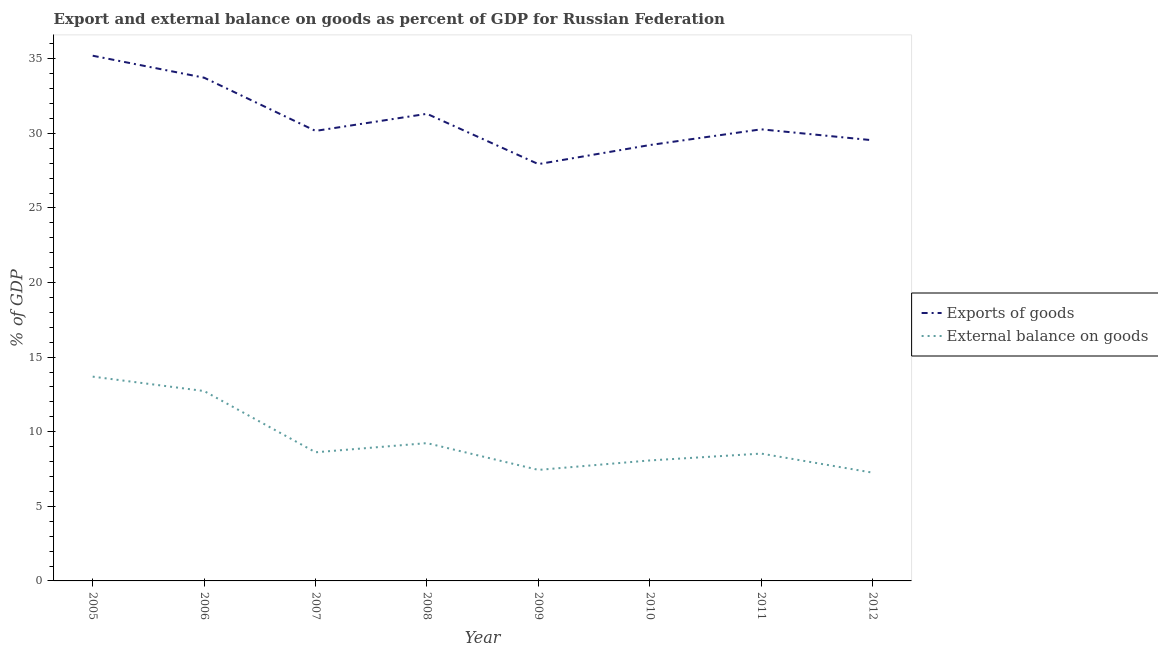Does the line corresponding to export of goods as percentage of gdp intersect with the line corresponding to external balance on goods as percentage of gdp?
Make the answer very short. No. What is the export of goods as percentage of gdp in 2012?
Keep it short and to the point. 29.54. Across all years, what is the maximum external balance on goods as percentage of gdp?
Your answer should be compact. 13.69. Across all years, what is the minimum external balance on goods as percentage of gdp?
Provide a succinct answer. 7.26. What is the total external balance on goods as percentage of gdp in the graph?
Offer a very short reply. 75.59. What is the difference between the external balance on goods as percentage of gdp in 2007 and that in 2008?
Offer a very short reply. -0.61. What is the difference between the export of goods as percentage of gdp in 2006 and the external balance on goods as percentage of gdp in 2005?
Offer a terse response. 20.04. What is the average external balance on goods as percentage of gdp per year?
Your answer should be very brief. 9.45. In the year 2005, what is the difference between the external balance on goods as percentage of gdp and export of goods as percentage of gdp?
Ensure brevity in your answer.  -21.51. In how many years, is the external balance on goods as percentage of gdp greater than 16 %?
Provide a succinct answer. 0. What is the ratio of the external balance on goods as percentage of gdp in 2007 to that in 2012?
Your answer should be compact. 1.19. Is the external balance on goods as percentage of gdp in 2008 less than that in 2010?
Ensure brevity in your answer.  No. Is the difference between the export of goods as percentage of gdp in 2007 and 2012 greater than the difference between the external balance on goods as percentage of gdp in 2007 and 2012?
Offer a very short reply. No. What is the difference between the highest and the second highest export of goods as percentage of gdp?
Your response must be concise. 1.47. What is the difference between the highest and the lowest export of goods as percentage of gdp?
Offer a terse response. 7.26. In how many years, is the external balance on goods as percentage of gdp greater than the average external balance on goods as percentage of gdp taken over all years?
Your answer should be compact. 2. Does the export of goods as percentage of gdp monotonically increase over the years?
Provide a succinct answer. No. Is the export of goods as percentage of gdp strictly greater than the external balance on goods as percentage of gdp over the years?
Offer a very short reply. Yes. Is the external balance on goods as percentage of gdp strictly less than the export of goods as percentage of gdp over the years?
Provide a succinct answer. Yes. What is the difference between two consecutive major ticks on the Y-axis?
Provide a succinct answer. 5. Are the values on the major ticks of Y-axis written in scientific E-notation?
Provide a short and direct response. No. Does the graph contain any zero values?
Your answer should be compact. No. Where does the legend appear in the graph?
Your answer should be very brief. Center right. What is the title of the graph?
Provide a short and direct response. Export and external balance on goods as percent of GDP for Russian Federation. Does "Travel services" appear as one of the legend labels in the graph?
Your answer should be compact. No. What is the label or title of the Y-axis?
Keep it short and to the point. % of GDP. What is the % of GDP of Exports of goods in 2005?
Your answer should be very brief. 35.2. What is the % of GDP in External balance on goods in 2005?
Your response must be concise. 13.69. What is the % of GDP of Exports of goods in 2006?
Provide a succinct answer. 33.73. What is the % of GDP of External balance on goods in 2006?
Make the answer very short. 12.73. What is the % of GDP in Exports of goods in 2007?
Provide a short and direct response. 30.16. What is the % of GDP in External balance on goods in 2007?
Provide a succinct answer. 8.62. What is the % of GDP of Exports of goods in 2008?
Your answer should be very brief. 31.31. What is the % of GDP in External balance on goods in 2008?
Provide a short and direct response. 9.24. What is the % of GDP in Exports of goods in 2009?
Keep it short and to the point. 27.94. What is the % of GDP of External balance on goods in 2009?
Keep it short and to the point. 7.44. What is the % of GDP of Exports of goods in 2010?
Provide a succinct answer. 29.22. What is the % of GDP of External balance on goods in 2010?
Provide a short and direct response. 8.08. What is the % of GDP in Exports of goods in 2011?
Give a very brief answer. 30.27. What is the % of GDP in External balance on goods in 2011?
Your response must be concise. 8.53. What is the % of GDP of Exports of goods in 2012?
Your answer should be very brief. 29.54. What is the % of GDP of External balance on goods in 2012?
Make the answer very short. 7.26. Across all years, what is the maximum % of GDP of Exports of goods?
Make the answer very short. 35.2. Across all years, what is the maximum % of GDP of External balance on goods?
Make the answer very short. 13.69. Across all years, what is the minimum % of GDP of Exports of goods?
Make the answer very short. 27.94. Across all years, what is the minimum % of GDP of External balance on goods?
Offer a very short reply. 7.26. What is the total % of GDP of Exports of goods in the graph?
Your answer should be very brief. 247.37. What is the total % of GDP in External balance on goods in the graph?
Offer a very short reply. 75.59. What is the difference between the % of GDP in Exports of goods in 2005 and that in 2006?
Your response must be concise. 1.47. What is the difference between the % of GDP of External balance on goods in 2005 and that in 2006?
Offer a terse response. 0.97. What is the difference between the % of GDP in Exports of goods in 2005 and that in 2007?
Your response must be concise. 5.04. What is the difference between the % of GDP of External balance on goods in 2005 and that in 2007?
Your response must be concise. 5.07. What is the difference between the % of GDP in Exports of goods in 2005 and that in 2008?
Your response must be concise. 3.89. What is the difference between the % of GDP in External balance on goods in 2005 and that in 2008?
Offer a terse response. 4.46. What is the difference between the % of GDP in Exports of goods in 2005 and that in 2009?
Offer a very short reply. 7.26. What is the difference between the % of GDP in External balance on goods in 2005 and that in 2009?
Your response must be concise. 6.25. What is the difference between the % of GDP in Exports of goods in 2005 and that in 2010?
Give a very brief answer. 5.99. What is the difference between the % of GDP of External balance on goods in 2005 and that in 2010?
Your answer should be compact. 5.62. What is the difference between the % of GDP of Exports of goods in 2005 and that in 2011?
Your answer should be very brief. 4.93. What is the difference between the % of GDP in External balance on goods in 2005 and that in 2011?
Ensure brevity in your answer.  5.16. What is the difference between the % of GDP of Exports of goods in 2005 and that in 2012?
Offer a very short reply. 5.67. What is the difference between the % of GDP of External balance on goods in 2005 and that in 2012?
Keep it short and to the point. 6.44. What is the difference between the % of GDP in Exports of goods in 2006 and that in 2007?
Offer a terse response. 3.57. What is the difference between the % of GDP of External balance on goods in 2006 and that in 2007?
Ensure brevity in your answer.  4.11. What is the difference between the % of GDP in Exports of goods in 2006 and that in 2008?
Give a very brief answer. 2.42. What is the difference between the % of GDP of External balance on goods in 2006 and that in 2008?
Keep it short and to the point. 3.49. What is the difference between the % of GDP of Exports of goods in 2006 and that in 2009?
Make the answer very short. 5.79. What is the difference between the % of GDP in External balance on goods in 2006 and that in 2009?
Your answer should be compact. 5.29. What is the difference between the % of GDP in Exports of goods in 2006 and that in 2010?
Your answer should be very brief. 4.51. What is the difference between the % of GDP in External balance on goods in 2006 and that in 2010?
Offer a terse response. 4.65. What is the difference between the % of GDP of Exports of goods in 2006 and that in 2011?
Make the answer very short. 3.46. What is the difference between the % of GDP of External balance on goods in 2006 and that in 2011?
Provide a short and direct response. 4.19. What is the difference between the % of GDP of Exports of goods in 2006 and that in 2012?
Provide a succinct answer. 4.19. What is the difference between the % of GDP in External balance on goods in 2006 and that in 2012?
Your answer should be compact. 5.47. What is the difference between the % of GDP in Exports of goods in 2007 and that in 2008?
Give a very brief answer. -1.15. What is the difference between the % of GDP in External balance on goods in 2007 and that in 2008?
Offer a very short reply. -0.61. What is the difference between the % of GDP of Exports of goods in 2007 and that in 2009?
Give a very brief answer. 2.23. What is the difference between the % of GDP of External balance on goods in 2007 and that in 2009?
Provide a succinct answer. 1.18. What is the difference between the % of GDP of Exports of goods in 2007 and that in 2010?
Keep it short and to the point. 0.95. What is the difference between the % of GDP of External balance on goods in 2007 and that in 2010?
Your answer should be very brief. 0.55. What is the difference between the % of GDP in Exports of goods in 2007 and that in 2011?
Provide a succinct answer. -0.11. What is the difference between the % of GDP of External balance on goods in 2007 and that in 2011?
Provide a short and direct response. 0.09. What is the difference between the % of GDP of Exports of goods in 2007 and that in 2012?
Ensure brevity in your answer.  0.63. What is the difference between the % of GDP of External balance on goods in 2007 and that in 2012?
Your answer should be compact. 1.37. What is the difference between the % of GDP in Exports of goods in 2008 and that in 2009?
Your answer should be very brief. 3.37. What is the difference between the % of GDP in External balance on goods in 2008 and that in 2009?
Make the answer very short. 1.8. What is the difference between the % of GDP in Exports of goods in 2008 and that in 2010?
Your answer should be very brief. 2.09. What is the difference between the % of GDP of External balance on goods in 2008 and that in 2010?
Give a very brief answer. 1.16. What is the difference between the % of GDP of Exports of goods in 2008 and that in 2011?
Offer a very short reply. 1.04. What is the difference between the % of GDP of External balance on goods in 2008 and that in 2011?
Your answer should be compact. 0.7. What is the difference between the % of GDP in Exports of goods in 2008 and that in 2012?
Provide a short and direct response. 1.77. What is the difference between the % of GDP in External balance on goods in 2008 and that in 2012?
Provide a succinct answer. 1.98. What is the difference between the % of GDP of Exports of goods in 2009 and that in 2010?
Make the answer very short. -1.28. What is the difference between the % of GDP of External balance on goods in 2009 and that in 2010?
Your answer should be very brief. -0.63. What is the difference between the % of GDP of Exports of goods in 2009 and that in 2011?
Provide a succinct answer. -2.33. What is the difference between the % of GDP in External balance on goods in 2009 and that in 2011?
Give a very brief answer. -1.09. What is the difference between the % of GDP in Exports of goods in 2009 and that in 2012?
Your answer should be compact. -1.6. What is the difference between the % of GDP in External balance on goods in 2009 and that in 2012?
Offer a very short reply. 0.18. What is the difference between the % of GDP in Exports of goods in 2010 and that in 2011?
Provide a short and direct response. -1.05. What is the difference between the % of GDP in External balance on goods in 2010 and that in 2011?
Give a very brief answer. -0.46. What is the difference between the % of GDP of Exports of goods in 2010 and that in 2012?
Offer a very short reply. -0.32. What is the difference between the % of GDP in External balance on goods in 2010 and that in 2012?
Provide a short and direct response. 0.82. What is the difference between the % of GDP in Exports of goods in 2011 and that in 2012?
Offer a terse response. 0.73. What is the difference between the % of GDP of External balance on goods in 2011 and that in 2012?
Provide a short and direct response. 1.28. What is the difference between the % of GDP in Exports of goods in 2005 and the % of GDP in External balance on goods in 2006?
Ensure brevity in your answer.  22.48. What is the difference between the % of GDP in Exports of goods in 2005 and the % of GDP in External balance on goods in 2007?
Make the answer very short. 26.58. What is the difference between the % of GDP in Exports of goods in 2005 and the % of GDP in External balance on goods in 2008?
Your response must be concise. 25.97. What is the difference between the % of GDP of Exports of goods in 2005 and the % of GDP of External balance on goods in 2009?
Your response must be concise. 27.76. What is the difference between the % of GDP in Exports of goods in 2005 and the % of GDP in External balance on goods in 2010?
Give a very brief answer. 27.13. What is the difference between the % of GDP in Exports of goods in 2005 and the % of GDP in External balance on goods in 2011?
Give a very brief answer. 26.67. What is the difference between the % of GDP in Exports of goods in 2005 and the % of GDP in External balance on goods in 2012?
Make the answer very short. 27.95. What is the difference between the % of GDP of Exports of goods in 2006 and the % of GDP of External balance on goods in 2007?
Your answer should be very brief. 25.11. What is the difference between the % of GDP in Exports of goods in 2006 and the % of GDP in External balance on goods in 2008?
Your response must be concise. 24.49. What is the difference between the % of GDP of Exports of goods in 2006 and the % of GDP of External balance on goods in 2009?
Keep it short and to the point. 26.29. What is the difference between the % of GDP of Exports of goods in 2006 and the % of GDP of External balance on goods in 2010?
Ensure brevity in your answer.  25.65. What is the difference between the % of GDP of Exports of goods in 2006 and the % of GDP of External balance on goods in 2011?
Your answer should be very brief. 25.2. What is the difference between the % of GDP in Exports of goods in 2006 and the % of GDP in External balance on goods in 2012?
Ensure brevity in your answer.  26.47. What is the difference between the % of GDP of Exports of goods in 2007 and the % of GDP of External balance on goods in 2008?
Give a very brief answer. 20.93. What is the difference between the % of GDP of Exports of goods in 2007 and the % of GDP of External balance on goods in 2009?
Your answer should be very brief. 22.72. What is the difference between the % of GDP of Exports of goods in 2007 and the % of GDP of External balance on goods in 2010?
Make the answer very short. 22.09. What is the difference between the % of GDP of Exports of goods in 2007 and the % of GDP of External balance on goods in 2011?
Provide a succinct answer. 21.63. What is the difference between the % of GDP in Exports of goods in 2007 and the % of GDP in External balance on goods in 2012?
Ensure brevity in your answer.  22.91. What is the difference between the % of GDP in Exports of goods in 2008 and the % of GDP in External balance on goods in 2009?
Your response must be concise. 23.87. What is the difference between the % of GDP in Exports of goods in 2008 and the % of GDP in External balance on goods in 2010?
Your response must be concise. 23.23. What is the difference between the % of GDP of Exports of goods in 2008 and the % of GDP of External balance on goods in 2011?
Your response must be concise. 22.78. What is the difference between the % of GDP of Exports of goods in 2008 and the % of GDP of External balance on goods in 2012?
Offer a terse response. 24.05. What is the difference between the % of GDP in Exports of goods in 2009 and the % of GDP in External balance on goods in 2010?
Your answer should be very brief. 19.86. What is the difference between the % of GDP in Exports of goods in 2009 and the % of GDP in External balance on goods in 2011?
Offer a very short reply. 19.4. What is the difference between the % of GDP of Exports of goods in 2009 and the % of GDP of External balance on goods in 2012?
Make the answer very short. 20.68. What is the difference between the % of GDP of Exports of goods in 2010 and the % of GDP of External balance on goods in 2011?
Make the answer very short. 20.68. What is the difference between the % of GDP in Exports of goods in 2010 and the % of GDP in External balance on goods in 2012?
Provide a short and direct response. 21.96. What is the difference between the % of GDP of Exports of goods in 2011 and the % of GDP of External balance on goods in 2012?
Offer a terse response. 23.01. What is the average % of GDP in Exports of goods per year?
Ensure brevity in your answer.  30.92. What is the average % of GDP in External balance on goods per year?
Offer a very short reply. 9.45. In the year 2005, what is the difference between the % of GDP in Exports of goods and % of GDP in External balance on goods?
Ensure brevity in your answer.  21.51. In the year 2006, what is the difference between the % of GDP in Exports of goods and % of GDP in External balance on goods?
Give a very brief answer. 21. In the year 2007, what is the difference between the % of GDP in Exports of goods and % of GDP in External balance on goods?
Your answer should be compact. 21.54. In the year 2008, what is the difference between the % of GDP of Exports of goods and % of GDP of External balance on goods?
Provide a short and direct response. 22.07. In the year 2009, what is the difference between the % of GDP of Exports of goods and % of GDP of External balance on goods?
Ensure brevity in your answer.  20.5. In the year 2010, what is the difference between the % of GDP of Exports of goods and % of GDP of External balance on goods?
Provide a short and direct response. 21.14. In the year 2011, what is the difference between the % of GDP in Exports of goods and % of GDP in External balance on goods?
Give a very brief answer. 21.73. In the year 2012, what is the difference between the % of GDP in Exports of goods and % of GDP in External balance on goods?
Provide a short and direct response. 22.28. What is the ratio of the % of GDP of Exports of goods in 2005 to that in 2006?
Offer a very short reply. 1.04. What is the ratio of the % of GDP in External balance on goods in 2005 to that in 2006?
Provide a succinct answer. 1.08. What is the ratio of the % of GDP in Exports of goods in 2005 to that in 2007?
Give a very brief answer. 1.17. What is the ratio of the % of GDP in External balance on goods in 2005 to that in 2007?
Provide a short and direct response. 1.59. What is the ratio of the % of GDP in Exports of goods in 2005 to that in 2008?
Make the answer very short. 1.12. What is the ratio of the % of GDP of External balance on goods in 2005 to that in 2008?
Offer a terse response. 1.48. What is the ratio of the % of GDP in Exports of goods in 2005 to that in 2009?
Provide a short and direct response. 1.26. What is the ratio of the % of GDP of External balance on goods in 2005 to that in 2009?
Give a very brief answer. 1.84. What is the ratio of the % of GDP in Exports of goods in 2005 to that in 2010?
Provide a succinct answer. 1.2. What is the ratio of the % of GDP of External balance on goods in 2005 to that in 2010?
Your answer should be compact. 1.7. What is the ratio of the % of GDP in Exports of goods in 2005 to that in 2011?
Offer a terse response. 1.16. What is the ratio of the % of GDP of External balance on goods in 2005 to that in 2011?
Give a very brief answer. 1.6. What is the ratio of the % of GDP of Exports of goods in 2005 to that in 2012?
Provide a succinct answer. 1.19. What is the ratio of the % of GDP in External balance on goods in 2005 to that in 2012?
Give a very brief answer. 1.89. What is the ratio of the % of GDP of Exports of goods in 2006 to that in 2007?
Keep it short and to the point. 1.12. What is the ratio of the % of GDP of External balance on goods in 2006 to that in 2007?
Ensure brevity in your answer.  1.48. What is the ratio of the % of GDP in Exports of goods in 2006 to that in 2008?
Provide a short and direct response. 1.08. What is the ratio of the % of GDP in External balance on goods in 2006 to that in 2008?
Offer a very short reply. 1.38. What is the ratio of the % of GDP of Exports of goods in 2006 to that in 2009?
Provide a succinct answer. 1.21. What is the ratio of the % of GDP of External balance on goods in 2006 to that in 2009?
Provide a succinct answer. 1.71. What is the ratio of the % of GDP in Exports of goods in 2006 to that in 2010?
Keep it short and to the point. 1.15. What is the ratio of the % of GDP of External balance on goods in 2006 to that in 2010?
Ensure brevity in your answer.  1.58. What is the ratio of the % of GDP of Exports of goods in 2006 to that in 2011?
Ensure brevity in your answer.  1.11. What is the ratio of the % of GDP in External balance on goods in 2006 to that in 2011?
Offer a very short reply. 1.49. What is the ratio of the % of GDP of Exports of goods in 2006 to that in 2012?
Offer a terse response. 1.14. What is the ratio of the % of GDP of External balance on goods in 2006 to that in 2012?
Your response must be concise. 1.75. What is the ratio of the % of GDP of Exports of goods in 2007 to that in 2008?
Ensure brevity in your answer.  0.96. What is the ratio of the % of GDP in External balance on goods in 2007 to that in 2008?
Your answer should be very brief. 0.93. What is the ratio of the % of GDP in Exports of goods in 2007 to that in 2009?
Offer a very short reply. 1.08. What is the ratio of the % of GDP in External balance on goods in 2007 to that in 2009?
Keep it short and to the point. 1.16. What is the ratio of the % of GDP of Exports of goods in 2007 to that in 2010?
Ensure brevity in your answer.  1.03. What is the ratio of the % of GDP of External balance on goods in 2007 to that in 2010?
Your answer should be very brief. 1.07. What is the ratio of the % of GDP of External balance on goods in 2007 to that in 2011?
Ensure brevity in your answer.  1.01. What is the ratio of the % of GDP of Exports of goods in 2007 to that in 2012?
Offer a very short reply. 1.02. What is the ratio of the % of GDP of External balance on goods in 2007 to that in 2012?
Offer a very short reply. 1.19. What is the ratio of the % of GDP in Exports of goods in 2008 to that in 2009?
Ensure brevity in your answer.  1.12. What is the ratio of the % of GDP of External balance on goods in 2008 to that in 2009?
Keep it short and to the point. 1.24. What is the ratio of the % of GDP of Exports of goods in 2008 to that in 2010?
Your response must be concise. 1.07. What is the ratio of the % of GDP of External balance on goods in 2008 to that in 2010?
Provide a succinct answer. 1.14. What is the ratio of the % of GDP in Exports of goods in 2008 to that in 2011?
Make the answer very short. 1.03. What is the ratio of the % of GDP in External balance on goods in 2008 to that in 2011?
Your response must be concise. 1.08. What is the ratio of the % of GDP of Exports of goods in 2008 to that in 2012?
Your response must be concise. 1.06. What is the ratio of the % of GDP of External balance on goods in 2008 to that in 2012?
Make the answer very short. 1.27. What is the ratio of the % of GDP in Exports of goods in 2009 to that in 2010?
Ensure brevity in your answer.  0.96. What is the ratio of the % of GDP in External balance on goods in 2009 to that in 2010?
Your answer should be compact. 0.92. What is the ratio of the % of GDP in Exports of goods in 2009 to that in 2011?
Make the answer very short. 0.92. What is the ratio of the % of GDP in External balance on goods in 2009 to that in 2011?
Your answer should be very brief. 0.87. What is the ratio of the % of GDP in Exports of goods in 2009 to that in 2012?
Keep it short and to the point. 0.95. What is the ratio of the % of GDP in External balance on goods in 2009 to that in 2012?
Offer a very short reply. 1.03. What is the ratio of the % of GDP of Exports of goods in 2010 to that in 2011?
Ensure brevity in your answer.  0.97. What is the ratio of the % of GDP of External balance on goods in 2010 to that in 2011?
Your response must be concise. 0.95. What is the ratio of the % of GDP of External balance on goods in 2010 to that in 2012?
Provide a short and direct response. 1.11. What is the ratio of the % of GDP of Exports of goods in 2011 to that in 2012?
Offer a terse response. 1.02. What is the ratio of the % of GDP in External balance on goods in 2011 to that in 2012?
Your response must be concise. 1.18. What is the difference between the highest and the second highest % of GDP in Exports of goods?
Provide a succinct answer. 1.47. What is the difference between the highest and the second highest % of GDP in External balance on goods?
Your answer should be very brief. 0.97. What is the difference between the highest and the lowest % of GDP in Exports of goods?
Provide a short and direct response. 7.26. What is the difference between the highest and the lowest % of GDP in External balance on goods?
Keep it short and to the point. 6.44. 